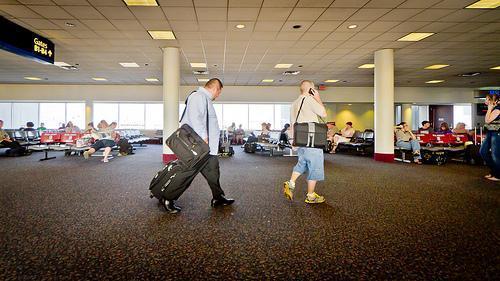How many columns are there?
Give a very brief answer. 2. 